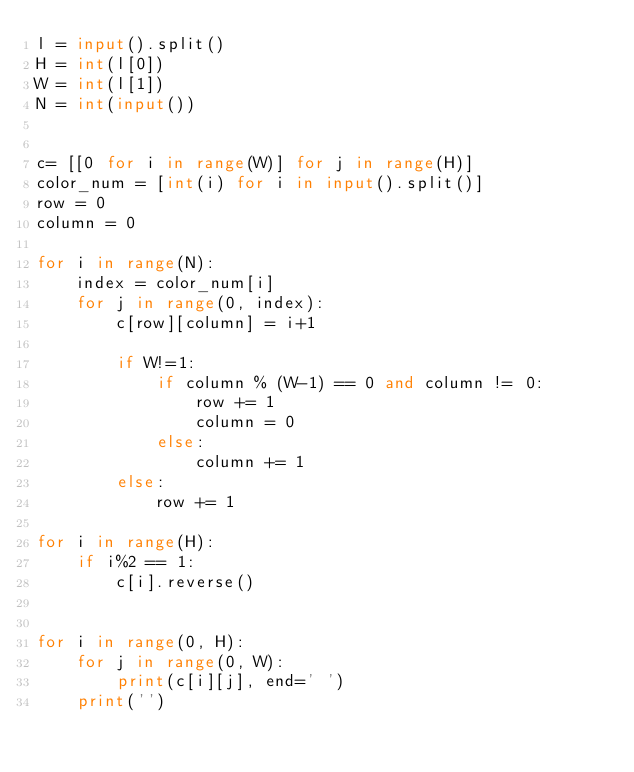Convert code to text. <code><loc_0><loc_0><loc_500><loc_500><_Python_>l = input().split()
H = int(l[0])
W = int(l[1])
N = int(input())


c= [[0 for i in range(W)] for j in range(H)]
color_num = [int(i) for i in input().split()]
row = 0
column = 0

for i in range(N):
    index = color_num[i]
    for j in range(0, index):
        c[row][column] = i+1

        if W!=1:
            if column % (W-1) == 0 and column != 0:
                row += 1
                column = 0
            else:
                column += 1
        else:
            row += 1

for i in range(H):
    if i%2 == 1:
        c[i].reverse()


for i in range(0, H):
    for j in range(0, W):
        print(c[i][j], end=' ')
    print('')</code> 